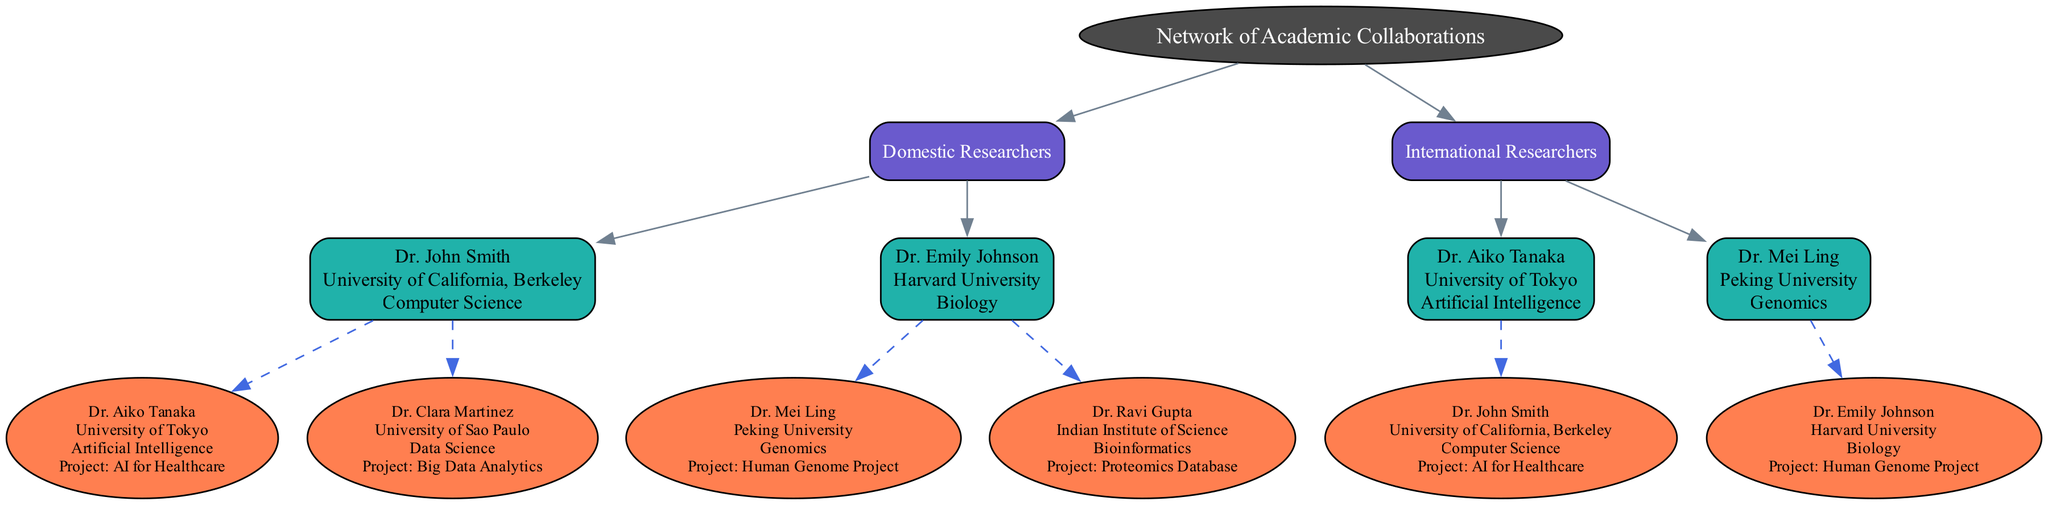What is the name of the root node? The root node is labeled "Network of Academic Collaborations," which is indicated at the top of the diagram as the primary node from which all other nodes branch out.
Answer: Network of Academic Collaborations How many domestic researchers are represented in the diagram? The diagram includes two domestic researchers: Dr. John Smith and Dr. Emily Johnson, under the "Domestic Researchers" category.
Answer: 2 What is the project associated with Dr. Aiko Tanaka? Dr. Aiko Tanaka collaborates on the "AI for Healthcare" project with Dr. John Smith, as shown in the collaborations listed under her information.
Answer: AI for Healthcare Who is the international collaborator of Dr. Emily Johnson? Dr. Emily Johnson's international collaborators are Dr. Mei Ling and Dr. Ravi Gupta, indicated in the collaborations section under her profile.
Answer: Dr. Mei Ling, Dr. Ravi Gupta Which institution is Dr. Clara Martinez associated with? Although Dr. Clara Martinez is mentioned as a collaborator in the diagram, she is associated with the University of Sao Paulo, which is specified in the sidebar of her information.
Answer: University of Sao Paulo Which field does Dr. Ravi Gupta specialize in? Dr. Ravi Gupta's specialty is in Bioinformatics, which is listed under his profile in the diagram.
Answer: Bioinformatics What is the relationship between Dr. John Smith and Dr. Mei Ling? Dr. John Smith collaborates with Dr. Aiko Tanaka, while Dr. Mei Ling collaborates with Dr. Emily Johnson; there is no direct relationship between them in the context of collaboration depicted in the diagram.
Answer: No direct relationship How many collaborations does Dr. John Smith have? Dr. John Smith has two international collaborations: one with Dr. Aiko Tanaka and another with Dr. Clara Martinez, as shown in his collaborations section.
Answer: 2 Which researcher is affiliated with Harvard University? The diagram specifies that Dr. Emily Johnson is affiliated with Harvard University, clearly stated under her profile.
Answer: Dr. Emily Johnson 